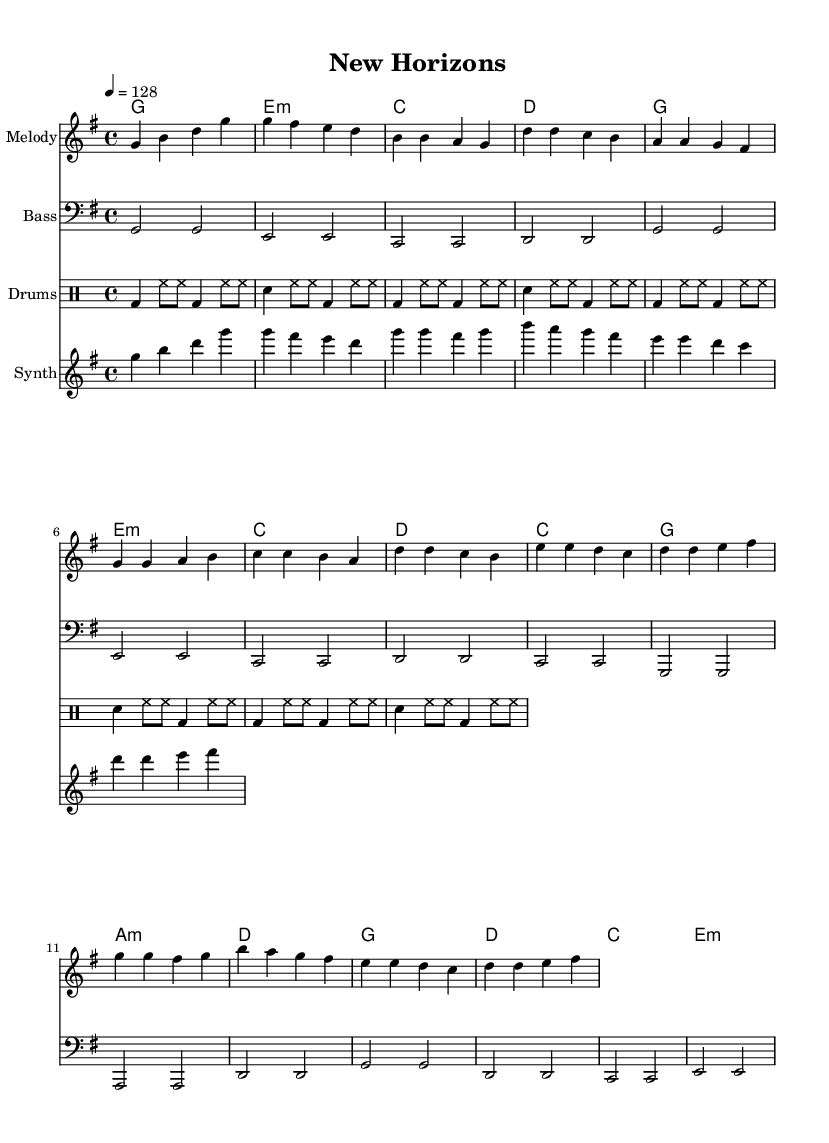What is the key signature of this music? The key signature indicates G major, which has one sharp (F#). This is determined by the initial part of the sheet music, where the key signature is defined.
Answer: G major What is the time signature of this music? The time signature shows 4/4 at the beginning of the sheet music, indicating four beats per measure with the quarter note getting one beat. This can be found at the start of the global music section.
Answer: 4/4 What is the tempo marking? The tempo marking states 4 = 128, indicating that the quarter note should be played at a speed of 128 beats per minute. This is specified in the global section.
Answer: 128 How many sections does the song have? The song consists of four main sections: Intro, Verse, Pre-Chorus, and Chorus. Each section is distinctively marked, making it clear where they begin and end.
Answer: Four What instrument plays the melody? The melody is indicated to be played on a staff labeled "Melody," which shows that this part is designated for a melodic instrument or voice.
Answer: Melody What type of instrument is used for the harmony? The harmony is played using chord names written above the staff, indicating the use of a harmonic instrument, typically a keyboard or guitar.
Answer: Chord names What rhythmic element is included in the drum pattern? The drum pattern includes bass drum (bd), snare drum (sn), and hi-hat (hh), which create a characteristic dance beat. This can be seen in the drummode part of the music.
Answer: Bass drum, snare drum, hi-hat 